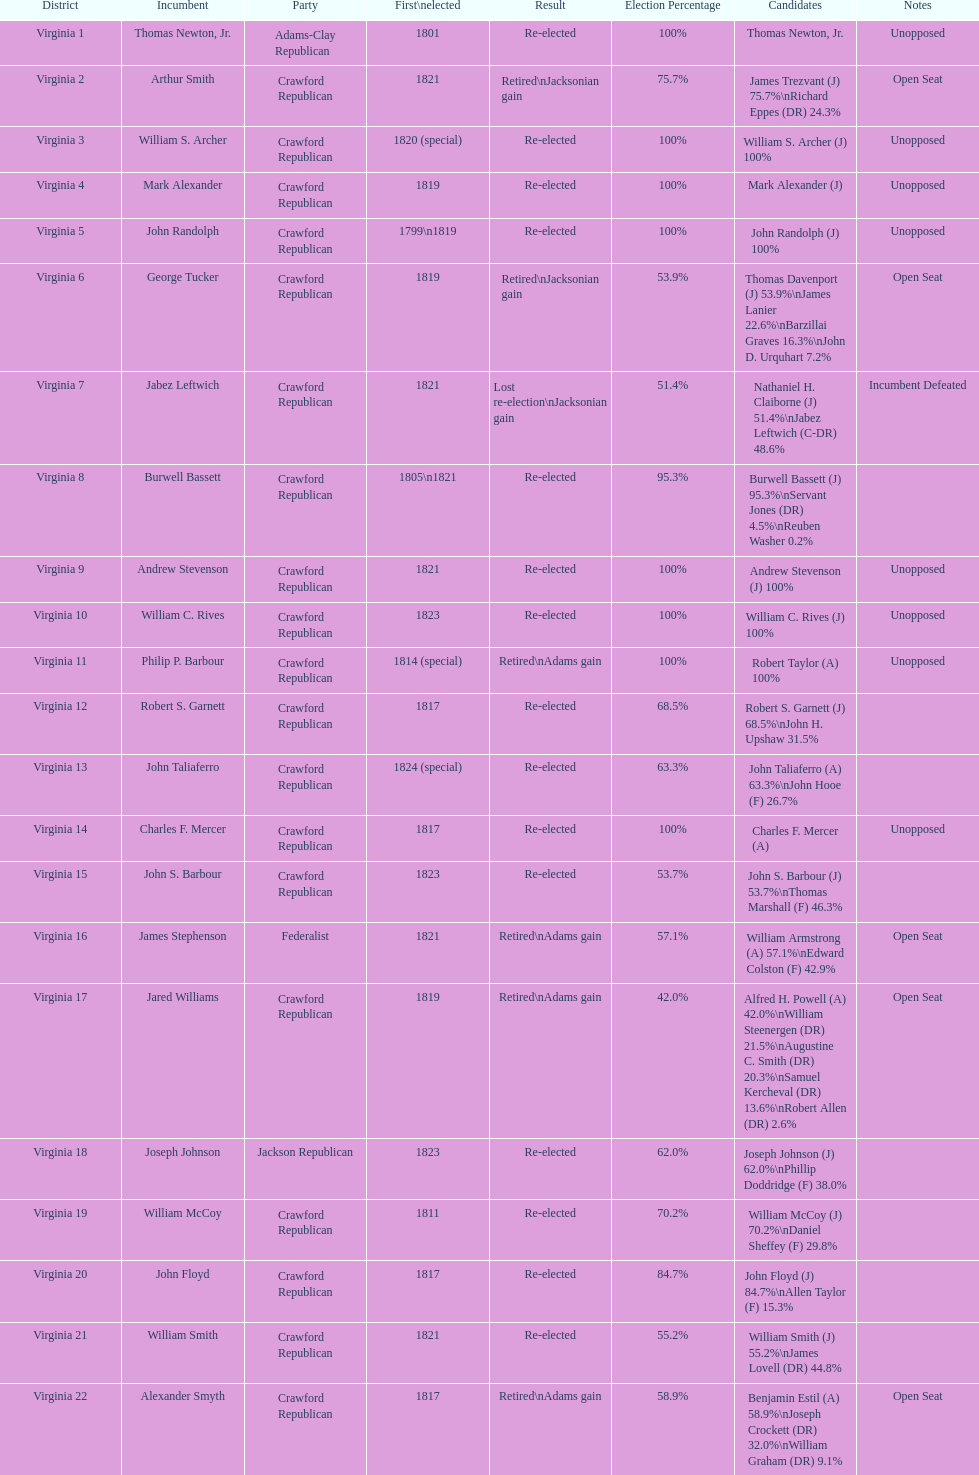What is the last party on this chart? Crawford Republican. 